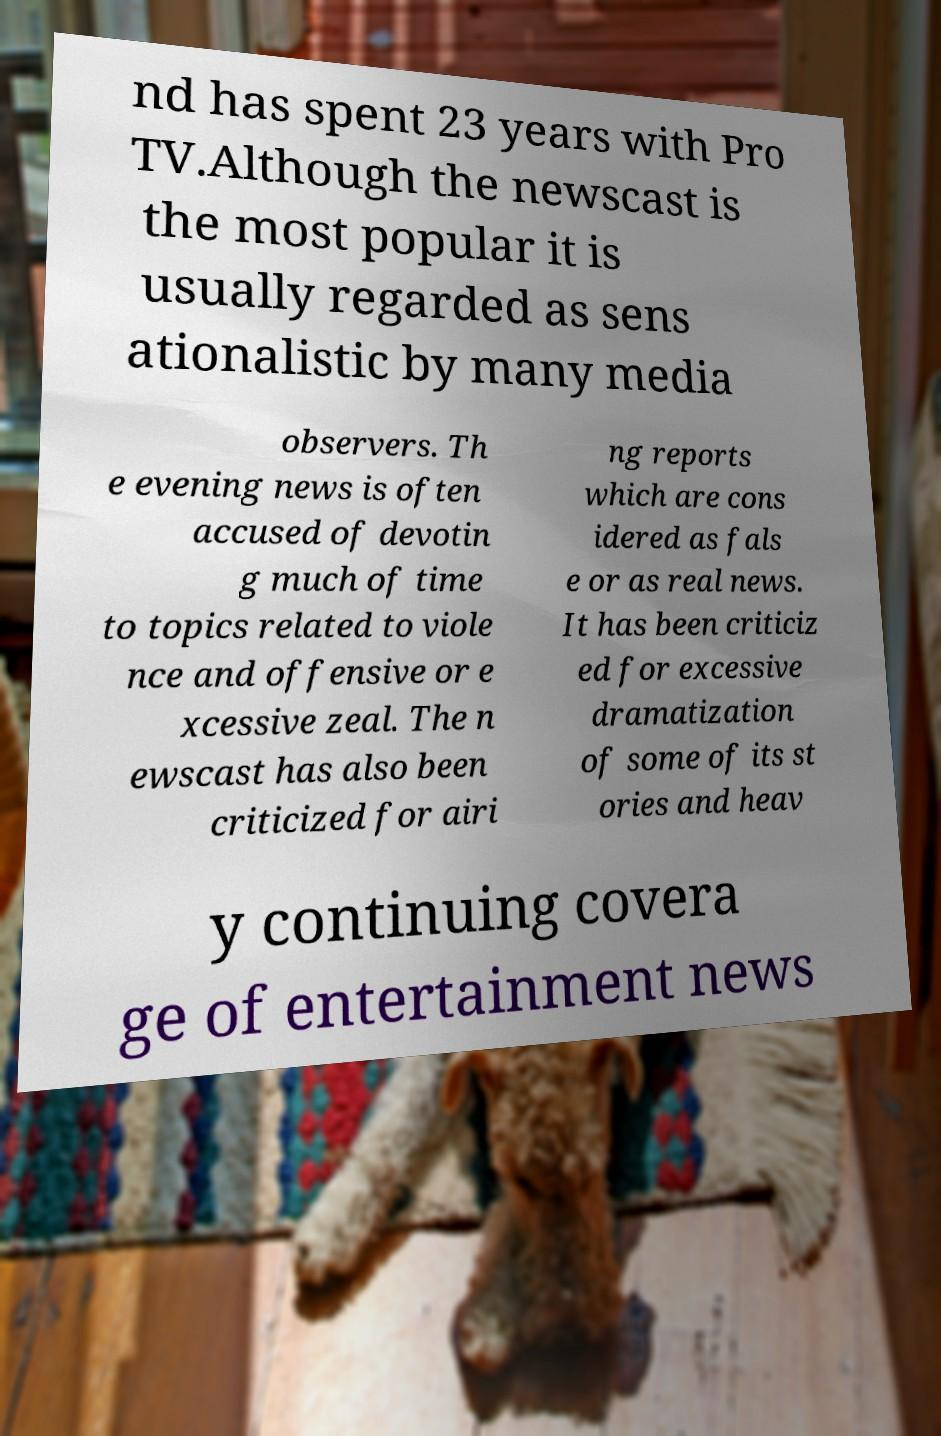There's text embedded in this image that I need extracted. Can you transcribe it verbatim? nd has spent 23 years with Pro TV.Although the newscast is the most popular it is usually regarded as sens ationalistic by many media observers. Th e evening news is often accused of devotin g much of time to topics related to viole nce and offensive or e xcessive zeal. The n ewscast has also been criticized for airi ng reports which are cons idered as fals e or as real news. It has been criticiz ed for excessive dramatization of some of its st ories and heav y continuing covera ge of entertainment news 